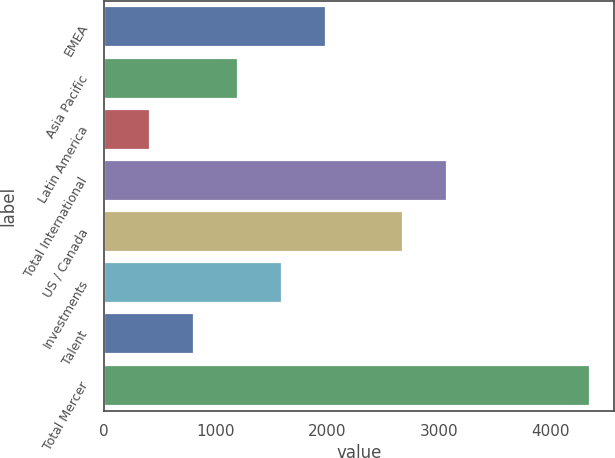Convert chart to OTSL. <chart><loc_0><loc_0><loc_500><loc_500><bar_chart><fcel>EMEA<fcel>Asia Pacific<fcel>Latin America<fcel>Total International<fcel>US / Canada<fcel>Investments<fcel>Talent<fcel>Total Mercer<nl><fcel>1987.8<fcel>1200.4<fcel>413<fcel>3076<fcel>2677<fcel>1594.1<fcel>806.7<fcel>4350<nl></chart> 